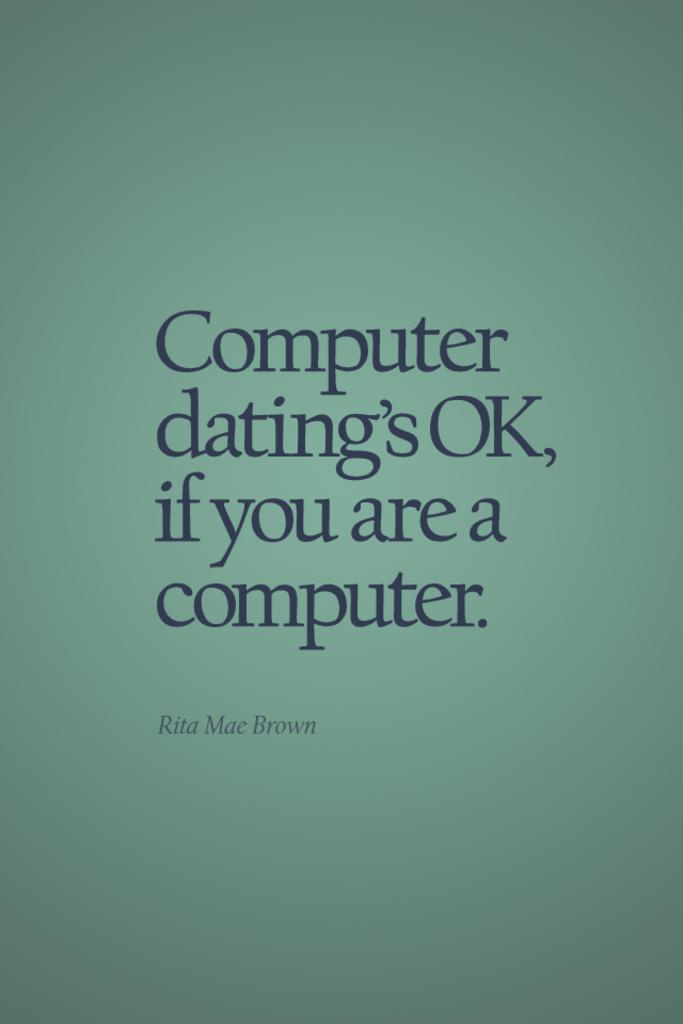<image>
Offer a succinct explanation of the picture presented. A green background with the slogan "Computer dating's OK, if you are a computer" written in blue letters. 